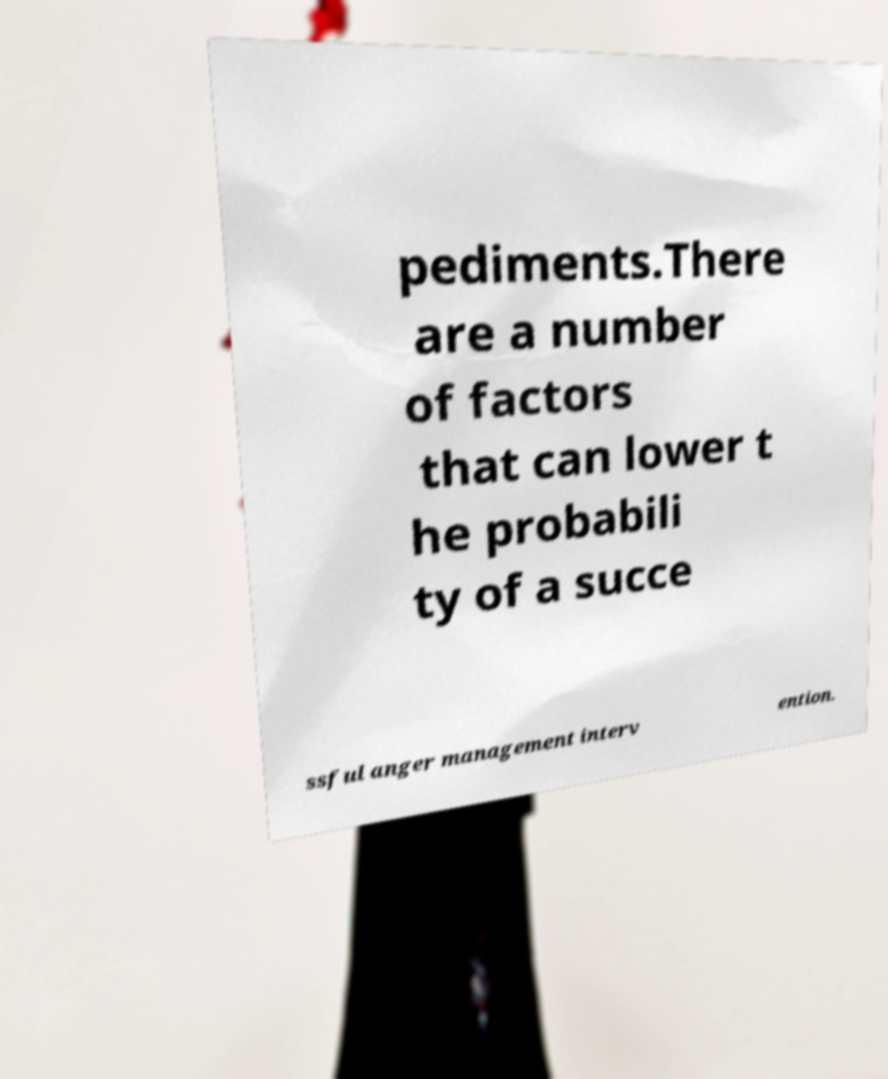I need the written content from this picture converted into text. Can you do that? pediments.There are a number of factors that can lower t he probabili ty of a succe ssful anger management interv ention. 